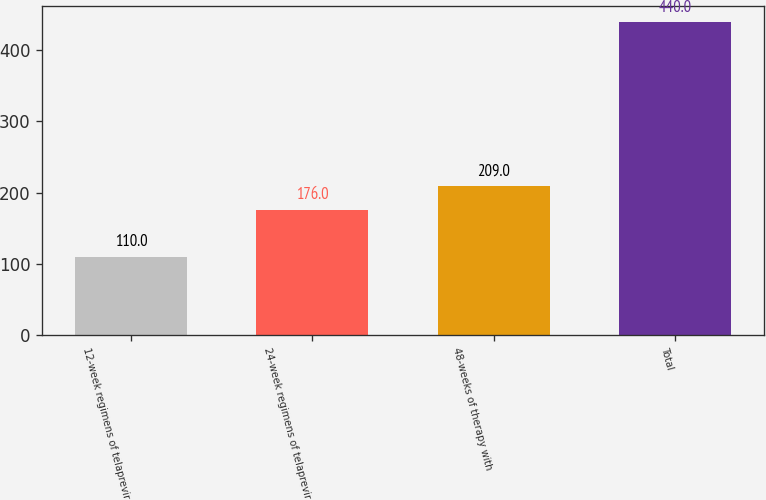Convert chart. <chart><loc_0><loc_0><loc_500><loc_500><bar_chart><fcel>12-week regimens of telaprevir<fcel>24-week regimens of telaprevir<fcel>48-weeks of therapy with<fcel>Total<nl><fcel>110<fcel>176<fcel>209<fcel>440<nl></chart> 